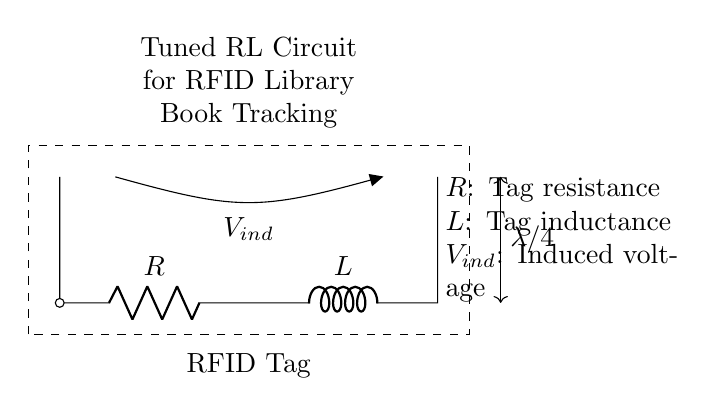What does the circuit contain? The circuit contains a resistor and an inductor, indicated by the symbols R and L. These are essential components of the tuned RL circuit.
Answer: Resistor and inductor What is the role of the antenna in this circuit? The antenna is used for transmitting or receiving signals, functioning as the interface between the RFID tag and the environment for communication purposes.
Answer: Transmission/reception What is the induced voltage denoted by? The induced voltage is denoted by V_ind, which represents the voltage generated across the inductor in response to changes in the magnetic field.
Answer: V_ind What is the relationship between the components in a tuned RL circuit? In a tuned RL circuit, the inductor and resistor interact to create resonance, which maximizes the circuit's response at a specific frequency.
Answer: Resonance interaction What should be achieved by tuning the circuit? Tuning the circuit aims to resonance frequency adjustment for optimal signal detection and performance in RFID applications.
Answer: Optimal signal detection What is the significance of the quarter-wavelength symbol shown? The quarter-wavelength symbol indicates the physical length of the antenna, tuned specifically for efficient operation at a certain frequency, which enhances communication capabilities.
Answer: Physical length of antenna What does a decrease in resistance imply for this circuit? A decrease in resistance will lead to an increase in current through the circuit when the voltage is constant, enhancing the overall response and efficiency of the RFID system.
Answer: Increase in current 